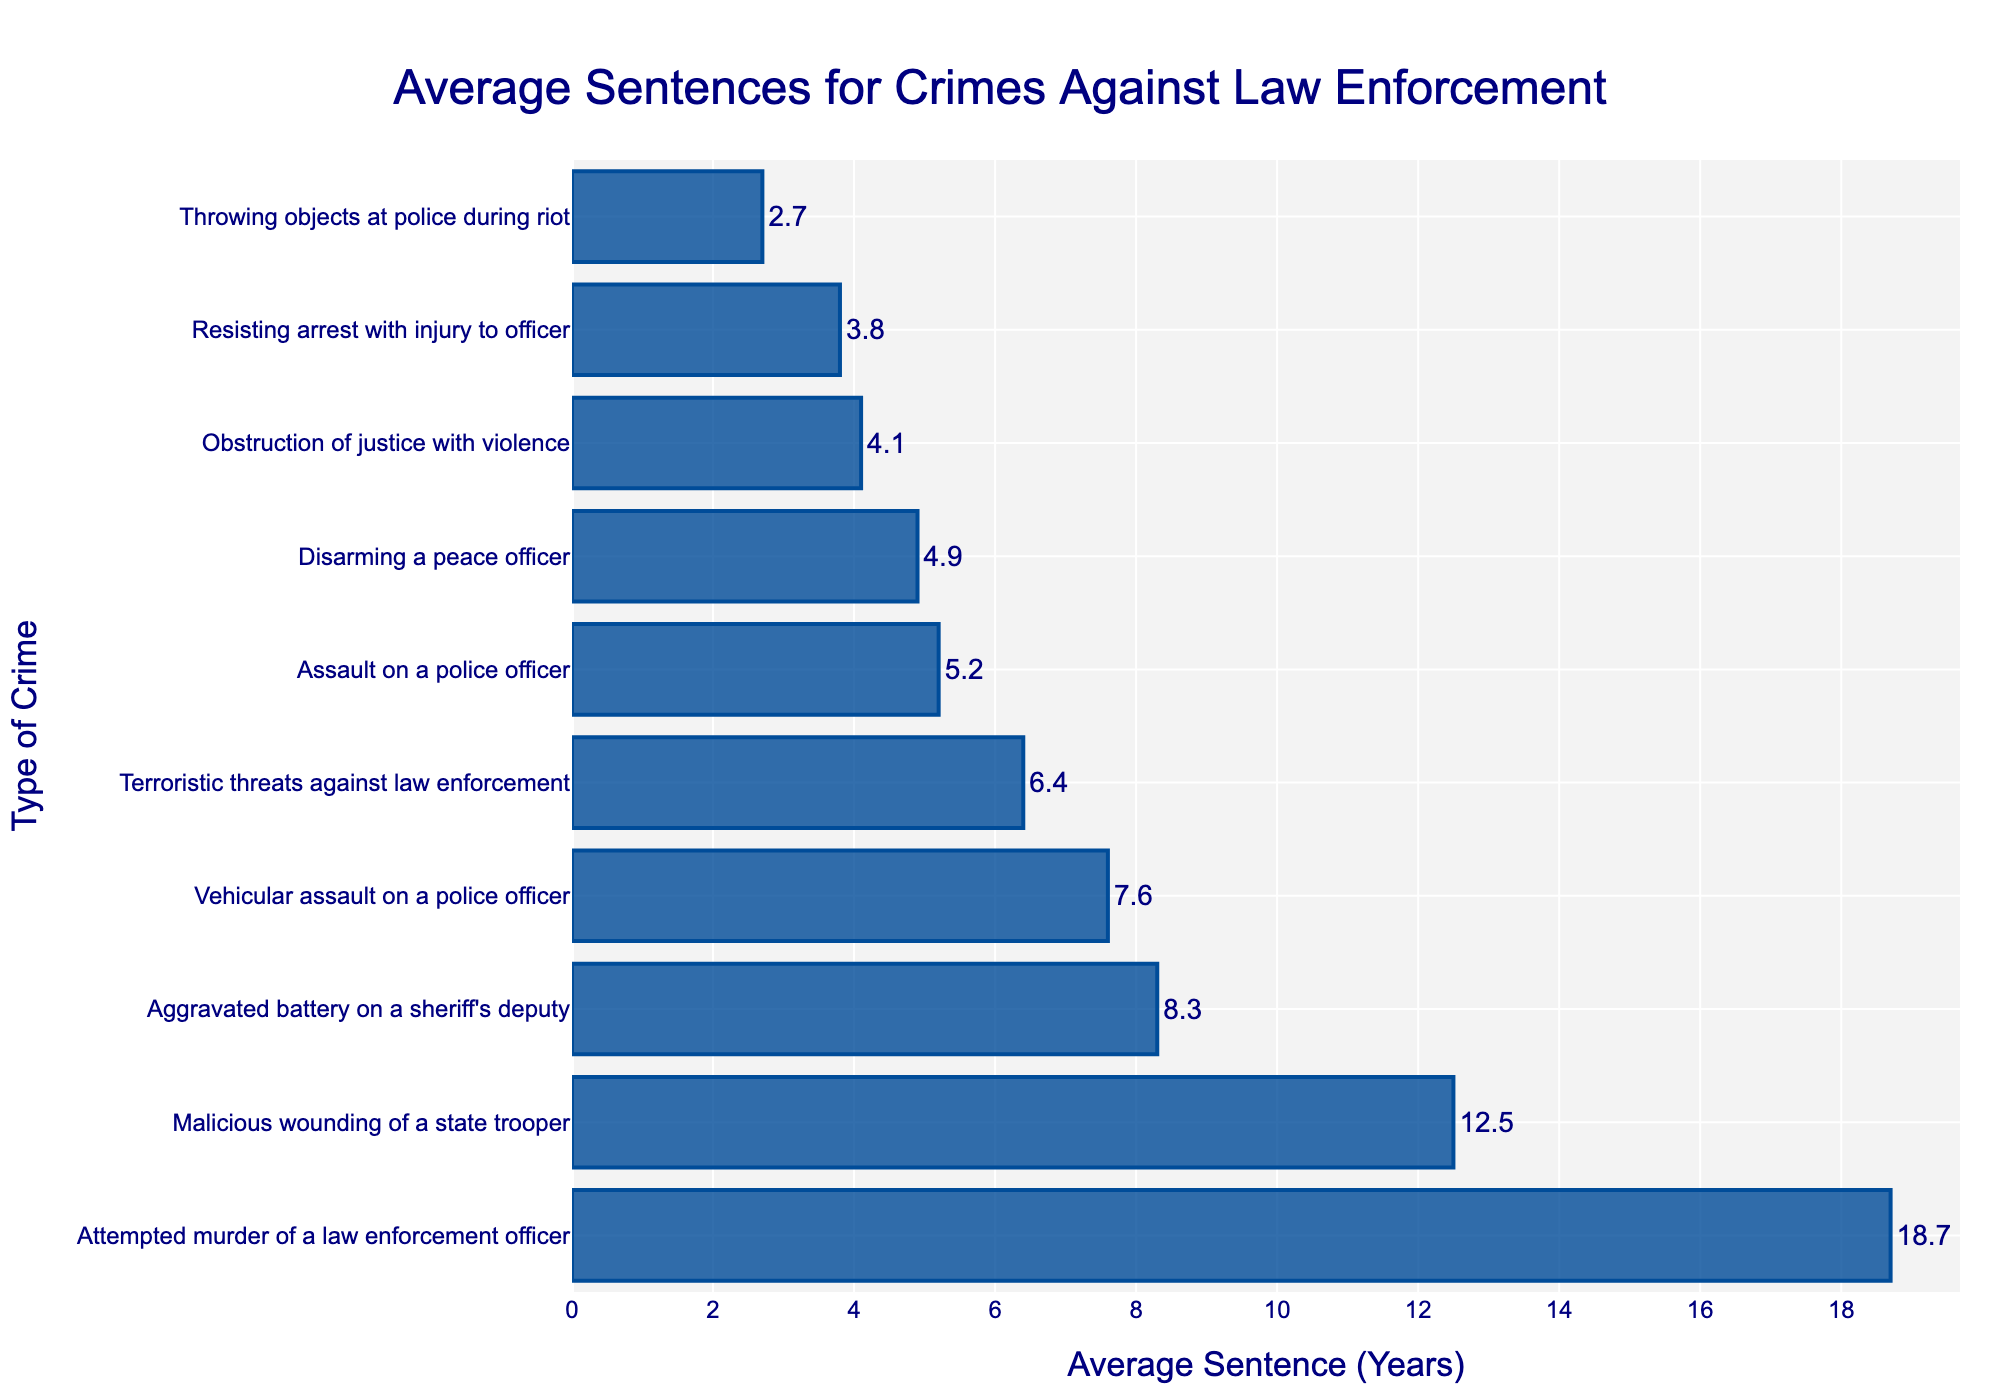Which crime has the longest average sentence? From the figure, the longest bar represents the crime with the highest average sentence, which is "Attempted murder of a law enforcement officer."
Answer: Attempted murder of a law enforcement officer What is the average sentence for aggravated battery on a sheriff's deputy? The bar for "Aggravated battery on a sheriff's deputy" shows an average sentence of 8.3 years.
Answer: 8.3 years Which crime has the shortest average sentence, and what is it? The shortest bar corresponds to "Throwing objects at police during riot," with an average sentence of 2.7 years.
Answer: Throwing objects at police during riot, 2.7 years How much longer is the average sentence for malicious wounding of a state trooper than for assault on a police officer? The average sentence for malicious wounding of a state trooper is 12.5 years, and for assault on a police officer, it is 5.2 years. The difference is 12.5 - 5.2 = 7.3 years.
Answer: 7.3 years Which crimes have an average sentence less than 5 years, and what are they? Crimes with bars that do not reach 5 years are "Resisting arrest with injury to officer," "Disarming a peace officer," "Obstruction of justice with violence," and "Throwing objects at police during riot." Their sentences are 3.8, 4.9, 4.1, and 2.7 years, respectively.
Answer: Resisting arrest with injury to officer, Disarming a peace officer, Obstruction of justice with violence, Throwing objects at police during riot What is the combined length of average sentences for disarming a peace officer and vehicular assault on a police officer? The average sentence for disarming a peace officer is 4.9 years, and for vehicular assault on a police officer, it is 7.6 years. Combined, it is 4.9 + 7.6 = 12.5 years.
Answer: 12.5 years Which crime has a longer average sentence, terroristic threats against law enforcement or vehicular assault on a police officer? The bar for vehicular assault on a police officer is longer than the one for terroristic threats against law enforcement, showing average sentences of 7.6 and 6.4 years, respectively.
Answer: Vehicular assault on a police officer How does the average sentence for obstruction of justice with violence compare to that of resisting arrest with injury to officer? Obstruction of justice with violence has an average sentence of 4.1 years, whereas resisting arrest with injury to officer has 3.8 years. Resisting arrest with injury to officer has a shorter average sentence.
Answer: Resisting arrest with injury to officer has a shorter sentence What proportion of sentences are 10 years or more? There are 3 crimes with average sentences of 10 years or more: Attempted murder of a law enforcement officer, malicious wounding of a state trooper, and aggravated battery on a sheriff's deputy. Out of 10 total crimes, 3/10 = 0.3 or 30%.
Answer: 30% 